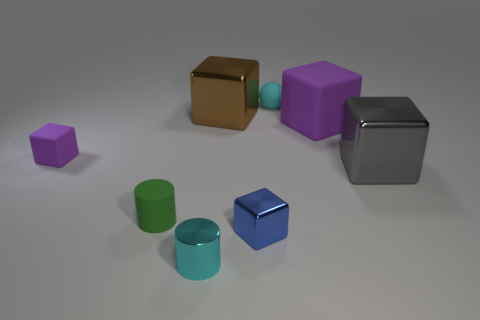Subtract all green cylinders. How many purple blocks are left? 2 Subtract all small metal cubes. How many cubes are left? 4 Subtract all purple blocks. How many blocks are left? 3 Add 2 small spheres. How many objects exist? 10 Subtract all gray cubes. Subtract all cyan cylinders. How many cubes are left? 4 Subtract all cylinders. How many objects are left? 6 Add 6 big purple cubes. How many big purple cubes are left? 7 Add 1 small green rubber things. How many small green rubber things exist? 2 Subtract 1 gray cubes. How many objects are left? 7 Subtract all large purple metal cylinders. Subtract all small matte things. How many objects are left? 5 